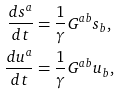<formula> <loc_0><loc_0><loc_500><loc_500>\frac { d s ^ { a } } { d t } & = \frac { 1 } { \gamma } G ^ { a b } s _ { b } , \\ \frac { d u ^ { a } } { d t } & = \frac { 1 } { \gamma } G ^ { a b } u _ { b } ,</formula> 